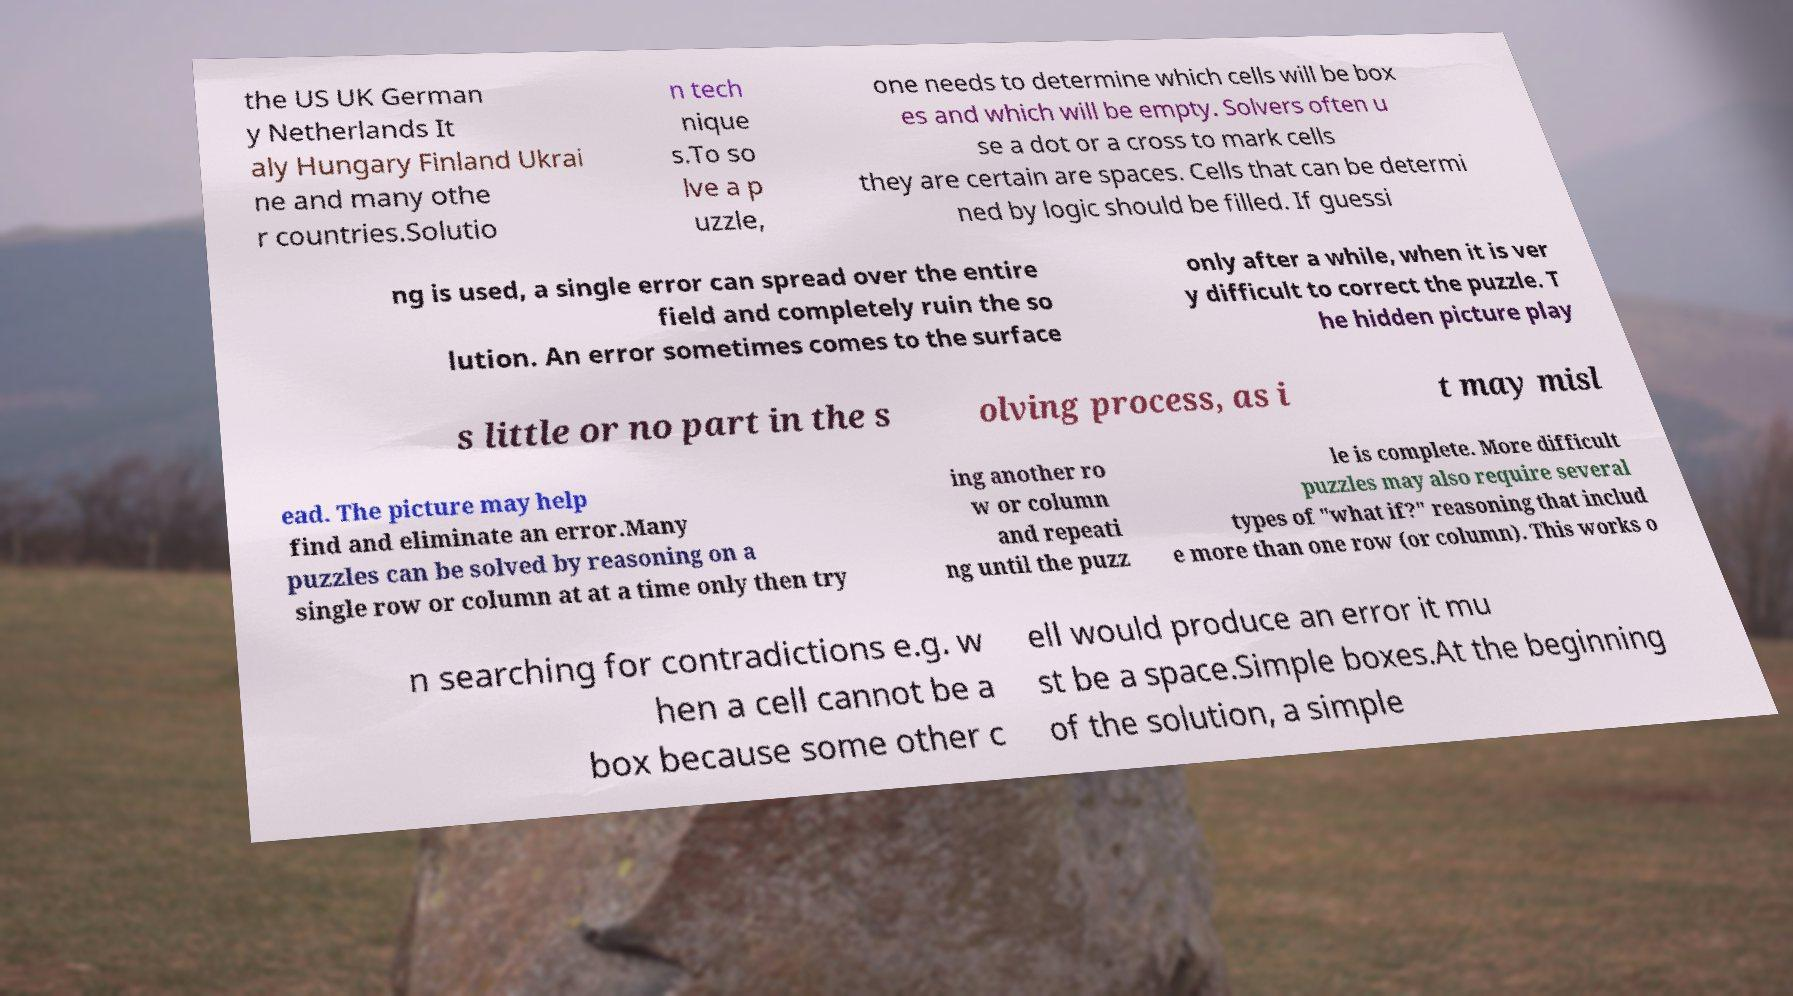For documentation purposes, I need the text within this image transcribed. Could you provide that? the US UK German y Netherlands It aly Hungary Finland Ukrai ne and many othe r countries.Solutio n tech nique s.To so lve a p uzzle, one needs to determine which cells will be box es and which will be empty. Solvers often u se a dot or a cross to mark cells they are certain are spaces. Cells that can be determi ned by logic should be filled. If guessi ng is used, a single error can spread over the entire field and completely ruin the so lution. An error sometimes comes to the surface only after a while, when it is ver y difficult to correct the puzzle. T he hidden picture play s little or no part in the s olving process, as i t may misl ead. The picture may help find and eliminate an error.Many puzzles can be solved by reasoning on a single row or column at at a time only then try ing another ro w or column and repeati ng until the puzz le is complete. More difficult puzzles may also require several types of "what if?" reasoning that includ e more than one row (or column). This works o n searching for contradictions e.g. w hen a cell cannot be a box because some other c ell would produce an error it mu st be a space.Simple boxes.At the beginning of the solution, a simple 